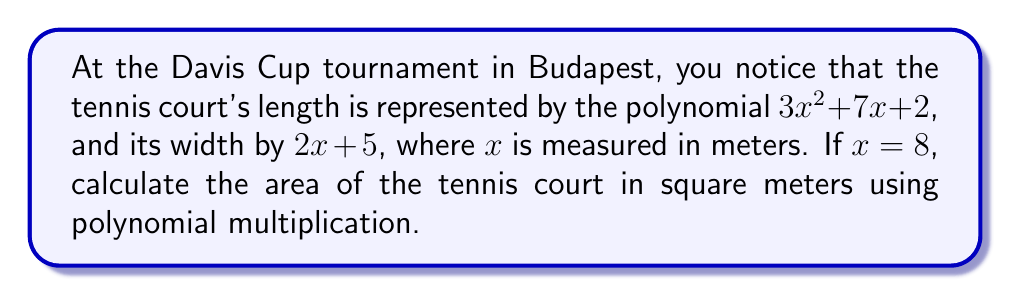Can you answer this question? Let's approach this step-by-step:

1) First, we need to find the length of the court by substituting $x = 8$ into the length polynomial:

   Length = $3x^2 + 7x + 2$
   $= 3(8)^2 + 7(8) + 2$
   $= 3(64) + 56 + 2$
   $= 192 + 56 + 2$
   $= 250$ meters

2) Next, we calculate the width by substituting $x = 8$ into the width polynomial:

   Width = $2x + 5$
   $= 2(8) + 5$
   $= 16 + 5$
   $= 21$ meters

3) To find the area, we multiply the length and width polynomials:

   Area = $(3x^2 + 7x + 2)(2x + 5)$

4) Let's use the FOIL method to multiply these polynomials:

   $= 3x^2(2x) + 3x^2(5) + 7x(2x) + 7x(5) + 2(2x) + 2(5)$
   $= 6x^3 + 15x^2 + 14x^2 + 35x + 4x + 10$
   $= 6x^3 + 29x^2 + 39x + 10$

5) Now, we substitute $x = 8$ into this polynomial:

   $= 6(8)^3 + 29(8)^2 + 39(8) + 10$
   $= 6(512) + 29(64) + 39(8) + 10$
   $= 3072 + 1856 + 312 + 10$
   $= 5250$ square meters

Therefore, the area of the tennis court is 5250 square meters.
Answer: 5250 m² 